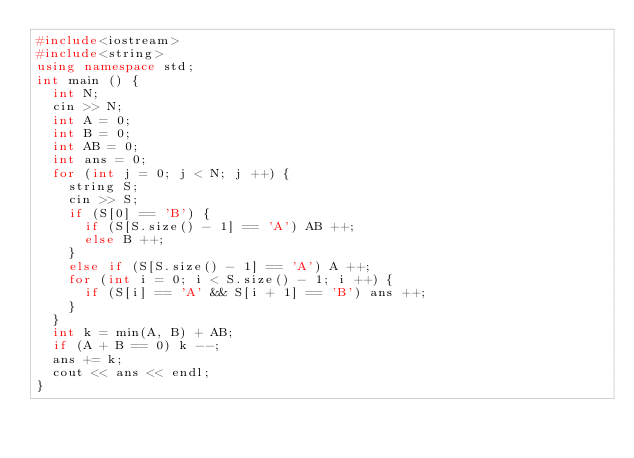<code> <loc_0><loc_0><loc_500><loc_500><_C++_>#include<iostream>
#include<string>
using namespace std;
int main () {
  int N;
  cin >> N;
  int A = 0;
  int B = 0;
  int AB = 0;
  int ans = 0;
  for (int j = 0; j < N; j ++) {
    string S;
    cin >> S;
    if (S[0] == 'B') {
      if (S[S.size() - 1] == 'A') AB ++;
      else B ++;
    }
    else if (S[S.size() - 1] == 'A') A ++;
    for (int i = 0; i < S.size() - 1; i ++) {
      if (S[i] == 'A' && S[i + 1] == 'B') ans ++;
    }
  }
  int k = min(A, B) + AB;
  if (A + B == 0) k --;
  ans += k;
  cout << ans << endl;
}

</code> 